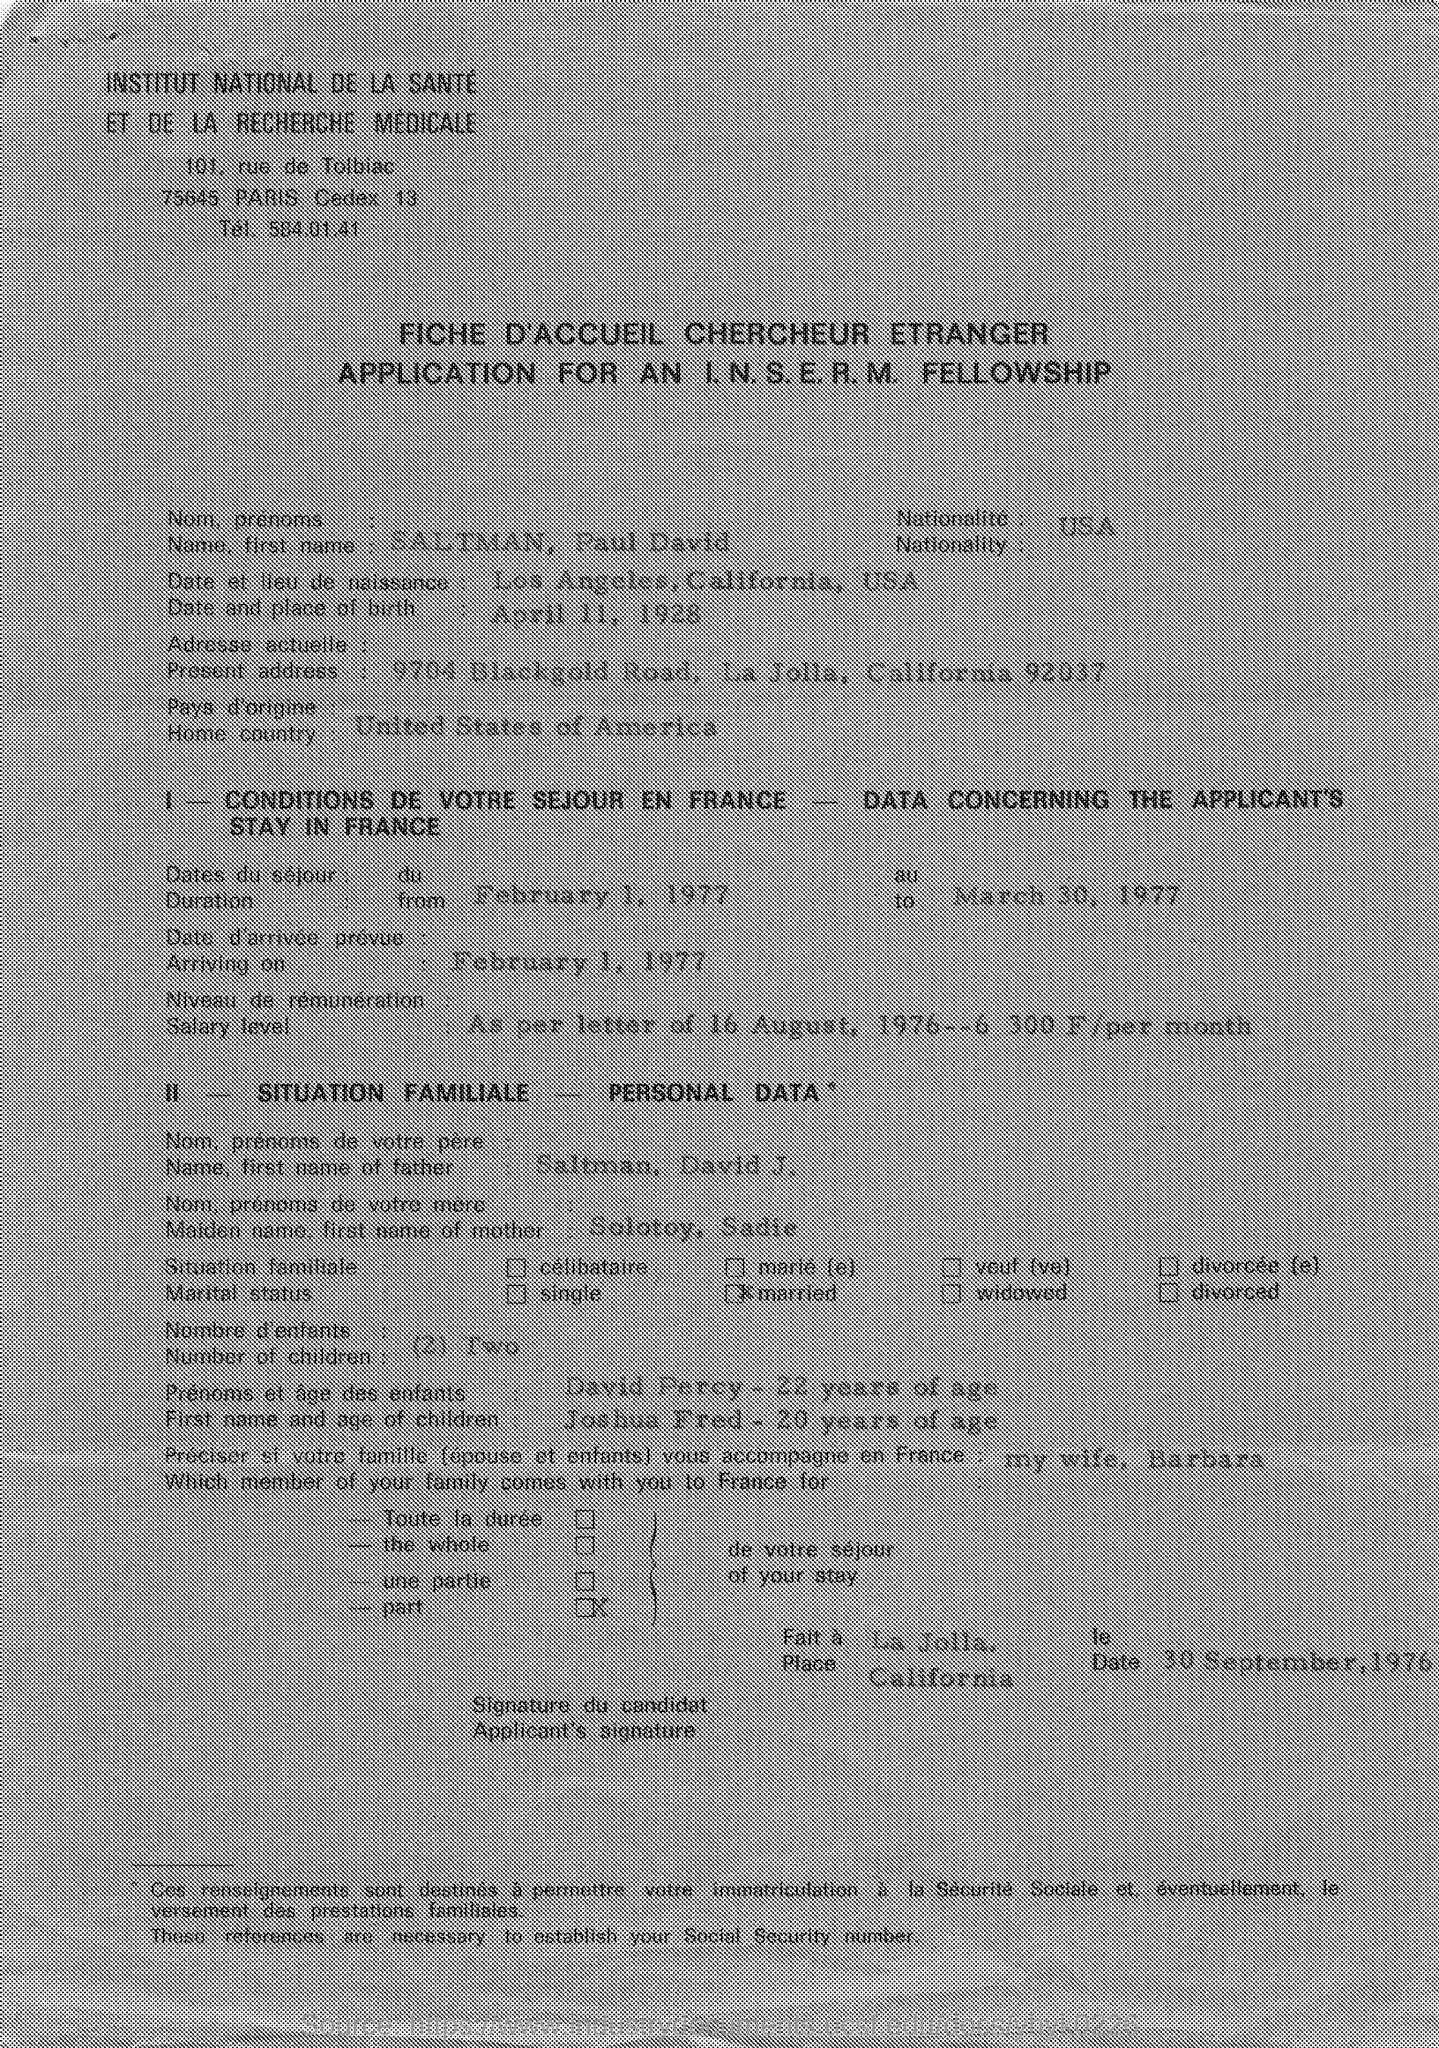Point out several critical features in this image. The arriving date mentioned in the given application is February 1, 1977. The present address mentioned in the given application is 9704 Blackgold road, La Jolla, California 92037. The nationality mentioned in the given application is American, specifically from the United States of America. The name of the person mentioned in the given application is Paul David Saltman. The given application states that the home country is the United States of America. 